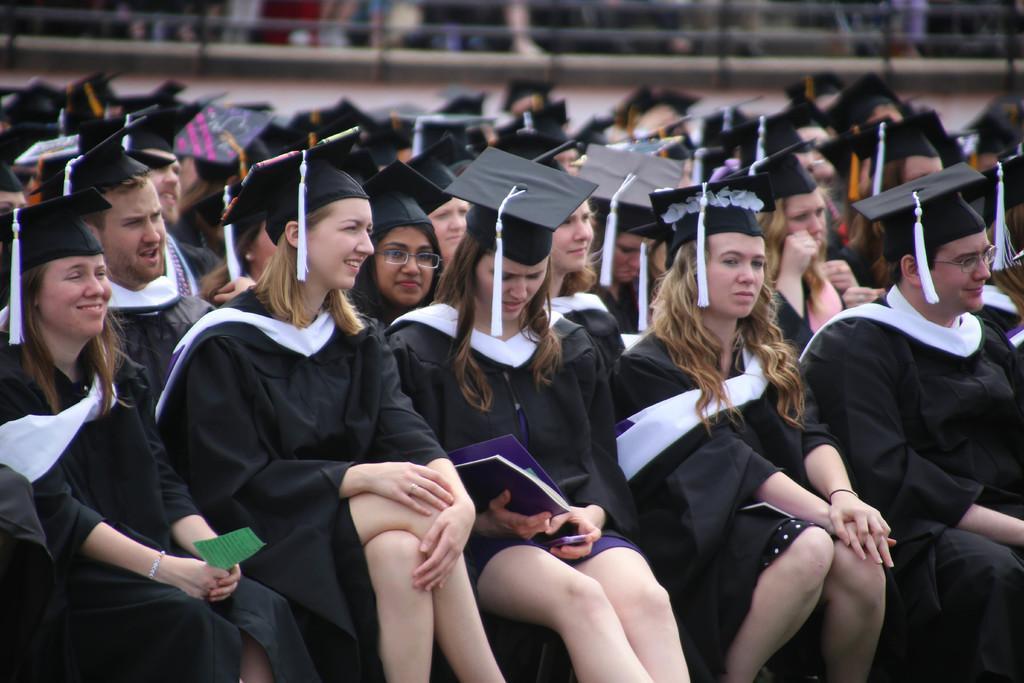Please provide a concise description of this image. There are group of people sitting and wore caps and she is holding a book and mobile. In the background we can see wall. 